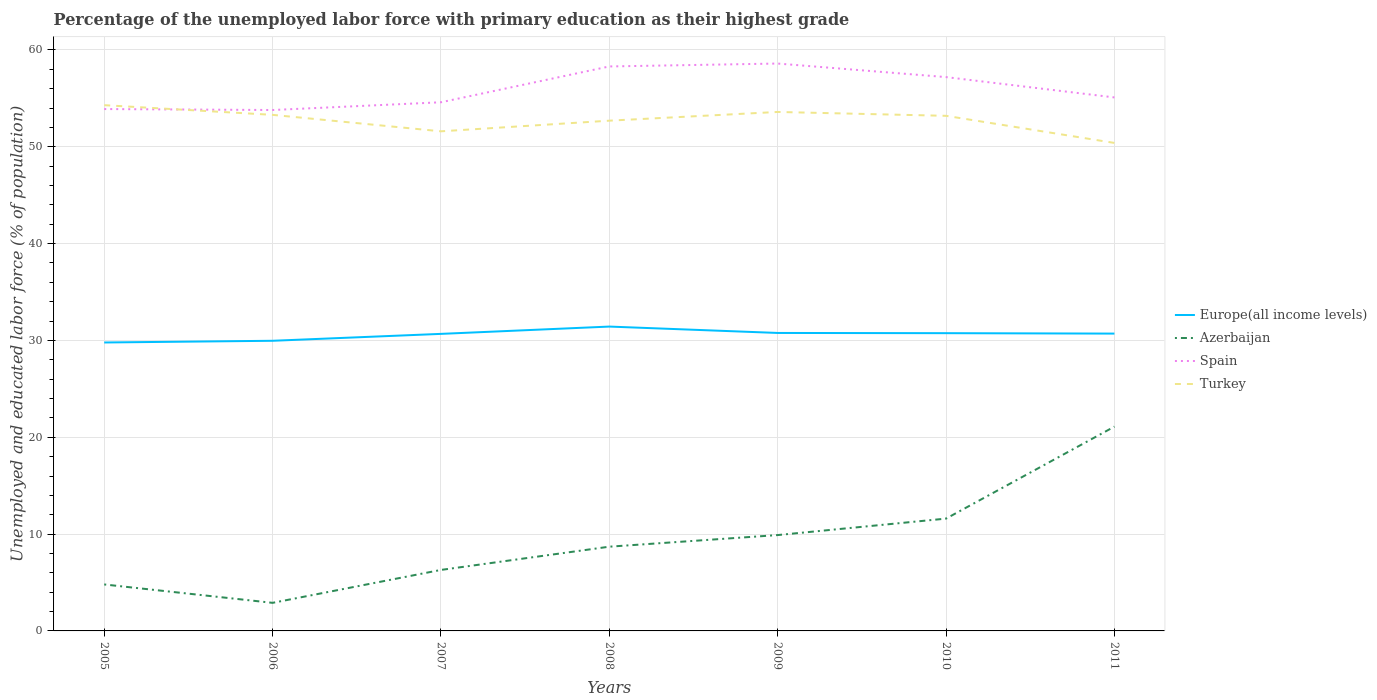How many different coloured lines are there?
Ensure brevity in your answer.  4. Does the line corresponding to Europe(all income levels) intersect with the line corresponding to Turkey?
Offer a terse response. No. Is the number of lines equal to the number of legend labels?
Ensure brevity in your answer.  Yes. Across all years, what is the maximum percentage of the unemployed labor force with primary education in Europe(all income levels)?
Provide a short and direct response. 29.79. In which year was the percentage of the unemployed labor force with primary education in Azerbaijan maximum?
Offer a terse response. 2006. What is the total percentage of the unemployed labor force with primary education in Azerbaijan in the graph?
Give a very brief answer. -3.6. What is the difference between the highest and the second highest percentage of the unemployed labor force with primary education in Turkey?
Make the answer very short. 3.9. What is the difference between the highest and the lowest percentage of the unemployed labor force with primary education in Spain?
Offer a very short reply. 3. How many lines are there?
Make the answer very short. 4. Are the values on the major ticks of Y-axis written in scientific E-notation?
Keep it short and to the point. No. Does the graph contain any zero values?
Your answer should be very brief. No. Where does the legend appear in the graph?
Keep it short and to the point. Center right. How many legend labels are there?
Your response must be concise. 4. How are the legend labels stacked?
Provide a short and direct response. Vertical. What is the title of the graph?
Your answer should be compact. Percentage of the unemployed labor force with primary education as their highest grade. What is the label or title of the Y-axis?
Provide a short and direct response. Unemployed and educated labor force (% of population). What is the Unemployed and educated labor force (% of population) of Europe(all income levels) in 2005?
Ensure brevity in your answer.  29.79. What is the Unemployed and educated labor force (% of population) of Azerbaijan in 2005?
Offer a terse response. 4.8. What is the Unemployed and educated labor force (% of population) in Spain in 2005?
Make the answer very short. 53.9. What is the Unemployed and educated labor force (% of population) of Turkey in 2005?
Give a very brief answer. 54.3. What is the Unemployed and educated labor force (% of population) in Europe(all income levels) in 2006?
Your response must be concise. 29.97. What is the Unemployed and educated labor force (% of population) of Azerbaijan in 2006?
Make the answer very short. 2.9. What is the Unemployed and educated labor force (% of population) of Spain in 2006?
Offer a very short reply. 53.8. What is the Unemployed and educated labor force (% of population) in Turkey in 2006?
Offer a very short reply. 53.3. What is the Unemployed and educated labor force (% of population) of Europe(all income levels) in 2007?
Your response must be concise. 30.68. What is the Unemployed and educated labor force (% of population) of Azerbaijan in 2007?
Offer a terse response. 6.3. What is the Unemployed and educated labor force (% of population) of Spain in 2007?
Your response must be concise. 54.6. What is the Unemployed and educated labor force (% of population) of Turkey in 2007?
Provide a short and direct response. 51.6. What is the Unemployed and educated labor force (% of population) in Europe(all income levels) in 2008?
Keep it short and to the point. 31.43. What is the Unemployed and educated labor force (% of population) of Azerbaijan in 2008?
Ensure brevity in your answer.  8.7. What is the Unemployed and educated labor force (% of population) in Spain in 2008?
Offer a terse response. 58.3. What is the Unemployed and educated labor force (% of population) of Turkey in 2008?
Provide a short and direct response. 52.7. What is the Unemployed and educated labor force (% of population) in Europe(all income levels) in 2009?
Your answer should be compact. 30.77. What is the Unemployed and educated labor force (% of population) in Azerbaijan in 2009?
Keep it short and to the point. 9.9. What is the Unemployed and educated labor force (% of population) in Spain in 2009?
Keep it short and to the point. 58.6. What is the Unemployed and educated labor force (% of population) in Turkey in 2009?
Offer a terse response. 53.6. What is the Unemployed and educated labor force (% of population) of Europe(all income levels) in 2010?
Provide a short and direct response. 30.75. What is the Unemployed and educated labor force (% of population) in Azerbaijan in 2010?
Make the answer very short. 11.6. What is the Unemployed and educated labor force (% of population) of Spain in 2010?
Keep it short and to the point. 57.2. What is the Unemployed and educated labor force (% of population) in Turkey in 2010?
Provide a succinct answer. 53.2. What is the Unemployed and educated labor force (% of population) in Europe(all income levels) in 2011?
Provide a succinct answer. 30.71. What is the Unemployed and educated labor force (% of population) in Azerbaijan in 2011?
Your response must be concise. 21.1. What is the Unemployed and educated labor force (% of population) in Spain in 2011?
Your answer should be compact. 55.1. What is the Unemployed and educated labor force (% of population) in Turkey in 2011?
Give a very brief answer. 50.4. Across all years, what is the maximum Unemployed and educated labor force (% of population) of Europe(all income levels)?
Your answer should be compact. 31.43. Across all years, what is the maximum Unemployed and educated labor force (% of population) of Azerbaijan?
Your answer should be compact. 21.1. Across all years, what is the maximum Unemployed and educated labor force (% of population) in Spain?
Your answer should be very brief. 58.6. Across all years, what is the maximum Unemployed and educated labor force (% of population) in Turkey?
Your answer should be very brief. 54.3. Across all years, what is the minimum Unemployed and educated labor force (% of population) in Europe(all income levels)?
Offer a very short reply. 29.79. Across all years, what is the minimum Unemployed and educated labor force (% of population) of Azerbaijan?
Keep it short and to the point. 2.9. Across all years, what is the minimum Unemployed and educated labor force (% of population) in Spain?
Offer a terse response. 53.8. Across all years, what is the minimum Unemployed and educated labor force (% of population) of Turkey?
Offer a very short reply. 50.4. What is the total Unemployed and educated labor force (% of population) in Europe(all income levels) in the graph?
Offer a terse response. 214.11. What is the total Unemployed and educated labor force (% of population) in Azerbaijan in the graph?
Ensure brevity in your answer.  65.3. What is the total Unemployed and educated labor force (% of population) of Spain in the graph?
Make the answer very short. 391.5. What is the total Unemployed and educated labor force (% of population) in Turkey in the graph?
Your response must be concise. 369.1. What is the difference between the Unemployed and educated labor force (% of population) of Europe(all income levels) in 2005 and that in 2006?
Provide a succinct answer. -0.17. What is the difference between the Unemployed and educated labor force (% of population) of Europe(all income levels) in 2005 and that in 2007?
Make the answer very short. -0.89. What is the difference between the Unemployed and educated labor force (% of population) in Azerbaijan in 2005 and that in 2007?
Provide a short and direct response. -1.5. What is the difference between the Unemployed and educated labor force (% of population) in Spain in 2005 and that in 2007?
Your response must be concise. -0.7. What is the difference between the Unemployed and educated labor force (% of population) in Europe(all income levels) in 2005 and that in 2008?
Offer a very short reply. -1.64. What is the difference between the Unemployed and educated labor force (% of population) of Azerbaijan in 2005 and that in 2008?
Keep it short and to the point. -3.9. What is the difference between the Unemployed and educated labor force (% of population) in Europe(all income levels) in 2005 and that in 2009?
Offer a terse response. -0.98. What is the difference between the Unemployed and educated labor force (% of population) of Azerbaijan in 2005 and that in 2009?
Keep it short and to the point. -5.1. What is the difference between the Unemployed and educated labor force (% of population) in Turkey in 2005 and that in 2009?
Ensure brevity in your answer.  0.7. What is the difference between the Unemployed and educated labor force (% of population) in Europe(all income levels) in 2005 and that in 2010?
Your answer should be compact. -0.96. What is the difference between the Unemployed and educated labor force (% of population) in Azerbaijan in 2005 and that in 2010?
Offer a terse response. -6.8. What is the difference between the Unemployed and educated labor force (% of population) of Spain in 2005 and that in 2010?
Your answer should be compact. -3.3. What is the difference between the Unemployed and educated labor force (% of population) in Turkey in 2005 and that in 2010?
Provide a short and direct response. 1.1. What is the difference between the Unemployed and educated labor force (% of population) of Europe(all income levels) in 2005 and that in 2011?
Offer a very short reply. -0.92. What is the difference between the Unemployed and educated labor force (% of population) of Azerbaijan in 2005 and that in 2011?
Offer a terse response. -16.3. What is the difference between the Unemployed and educated labor force (% of population) of Europe(all income levels) in 2006 and that in 2007?
Offer a very short reply. -0.71. What is the difference between the Unemployed and educated labor force (% of population) of Turkey in 2006 and that in 2007?
Provide a short and direct response. 1.7. What is the difference between the Unemployed and educated labor force (% of population) in Europe(all income levels) in 2006 and that in 2008?
Your answer should be compact. -1.47. What is the difference between the Unemployed and educated labor force (% of population) of Azerbaijan in 2006 and that in 2008?
Your response must be concise. -5.8. What is the difference between the Unemployed and educated labor force (% of population) in Europe(all income levels) in 2006 and that in 2009?
Keep it short and to the point. -0.81. What is the difference between the Unemployed and educated labor force (% of population) in Azerbaijan in 2006 and that in 2009?
Ensure brevity in your answer.  -7. What is the difference between the Unemployed and educated labor force (% of population) in Turkey in 2006 and that in 2009?
Your answer should be very brief. -0.3. What is the difference between the Unemployed and educated labor force (% of population) of Europe(all income levels) in 2006 and that in 2010?
Provide a succinct answer. -0.79. What is the difference between the Unemployed and educated labor force (% of population) in Azerbaijan in 2006 and that in 2010?
Provide a short and direct response. -8.7. What is the difference between the Unemployed and educated labor force (% of population) of Spain in 2006 and that in 2010?
Give a very brief answer. -3.4. What is the difference between the Unemployed and educated labor force (% of population) of Turkey in 2006 and that in 2010?
Keep it short and to the point. 0.1. What is the difference between the Unemployed and educated labor force (% of population) of Europe(all income levels) in 2006 and that in 2011?
Your answer should be very brief. -0.74. What is the difference between the Unemployed and educated labor force (% of population) of Azerbaijan in 2006 and that in 2011?
Ensure brevity in your answer.  -18.2. What is the difference between the Unemployed and educated labor force (% of population) of Spain in 2006 and that in 2011?
Give a very brief answer. -1.3. What is the difference between the Unemployed and educated labor force (% of population) of Turkey in 2006 and that in 2011?
Your response must be concise. 2.9. What is the difference between the Unemployed and educated labor force (% of population) of Europe(all income levels) in 2007 and that in 2008?
Your answer should be very brief. -0.75. What is the difference between the Unemployed and educated labor force (% of population) in Europe(all income levels) in 2007 and that in 2009?
Provide a short and direct response. -0.09. What is the difference between the Unemployed and educated labor force (% of population) in Azerbaijan in 2007 and that in 2009?
Keep it short and to the point. -3.6. What is the difference between the Unemployed and educated labor force (% of population) in Europe(all income levels) in 2007 and that in 2010?
Offer a very short reply. -0.07. What is the difference between the Unemployed and educated labor force (% of population) of Spain in 2007 and that in 2010?
Offer a terse response. -2.6. What is the difference between the Unemployed and educated labor force (% of population) of Turkey in 2007 and that in 2010?
Offer a very short reply. -1.6. What is the difference between the Unemployed and educated labor force (% of population) in Europe(all income levels) in 2007 and that in 2011?
Give a very brief answer. -0.03. What is the difference between the Unemployed and educated labor force (% of population) in Azerbaijan in 2007 and that in 2011?
Offer a very short reply. -14.8. What is the difference between the Unemployed and educated labor force (% of population) in Spain in 2007 and that in 2011?
Ensure brevity in your answer.  -0.5. What is the difference between the Unemployed and educated labor force (% of population) of Europe(all income levels) in 2008 and that in 2009?
Offer a terse response. 0.66. What is the difference between the Unemployed and educated labor force (% of population) in Turkey in 2008 and that in 2009?
Offer a very short reply. -0.9. What is the difference between the Unemployed and educated labor force (% of population) of Europe(all income levels) in 2008 and that in 2010?
Offer a very short reply. 0.68. What is the difference between the Unemployed and educated labor force (% of population) of Turkey in 2008 and that in 2010?
Offer a very short reply. -0.5. What is the difference between the Unemployed and educated labor force (% of population) of Europe(all income levels) in 2008 and that in 2011?
Keep it short and to the point. 0.73. What is the difference between the Unemployed and educated labor force (% of population) in Spain in 2008 and that in 2011?
Offer a terse response. 3.2. What is the difference between the Unemployed and educated labor force (% of population) in Turkey in 2008 and that in 2011?
Ensure brevity in your answer.  2.3. What is the difference between the Unemployed and educated labor force (% of population) of Europe(all income levels) in 2009 and that in 2010?
Keep it short and to the point. 0.02. What is the difference between the Unemployed and educated labor force (% of population) of Spain in 2009 and that in 2010?
Your answer should be very brief. 1.4. What is the difference between the Unemployed and educated labor force (% of population) in Turkey in 2009 and that in 2010?
Provide a succinct answer. 0.4. What is the difference between the Unemployed and educated labor force (% of population) in Europe(all income levels) in 2009 and that in 2011?
Your response must be concise. 0.07. What is the difference between the Unemployed and educated labor force (% of population) of Azerbaijan in 2009 and that in 2011?
Ensure brevity in your answer.  -11.2. What is the difference between the Unemployed and educated labor force (% of population) in Spain in 2009 and that in 2011?
Your answer should be compact. 3.5. What is the difference between the Unemployed and educated labor force (% of population) in Europe(all income levels) in 2010 and that in 2011?
Keep it short and to the point. 0.04. What is the difference between the Unemployed and educated labor force (% of population) in Azerbaijan in 2010 and that in 2011?
Offer a terse response. -9.5. What is the difference between the Unemployed and educated labor force (% of population) of Spain in 2010 and that in 2011?
Give a very brief answer. 2.1. What is the difference between the Unemployed and educated labor force (% of population) of Europe(all income levels) in 2005 and the Unemployed and educated labor force (% of population) of Azerbaijan in 2006?
Provide a short and direct response. 26.89. What is the difference between the Unemployed and educated labor force (% of population) in Europe(all income levels) in 2005 and the Unemployed and educated labor force (% of population) in Spain in 2006?
Keep it short and to the point. -24.01. What is the difference between the Unemployed and educated labor force (% of population) in Europe(all income levels) in 2005 and the Unemployed and educated labor force (% of population) in Turkey in 2006?
Ensure brevity in your answer.  -23.51. What is the difference between the Unemployed and educated labor force (% of population) in Azerbaijan in 2005 and the Unemployed and educated labor force (% of population) in Spain in 2006?
Your answer should be very brief. -49. What is the difference between the Unemployed and educated labor force (% of population) in Azerbaijan in 2005 and the Unemployed and educated labor force (% of population) in Turkey in 2006?
Your answer should be compact. -48.5. What is the difference between the Unemployed and educated labor force (% of population) of Europe(all income levels) in 2005 and the Unemployed and educated labor force (% of population) of Azerbaijan in 2007?
Your answer should be very brief. 23.49. What is the difference between the Unemployed and educated labor force (% of population) in Europe(all income levels) in 2005 and the Unemployed and educated labor force (% of population) in Spain in 2007?
Your answer should be very brief. -24.81. What is the difference between the Unemployed and educated labor force (% of population) of Europe(all income levels) in 2005 and the Unemployed and educated labor force (% of population) of Turkey in 2007?
Your response must be concise. -21.81. What is the difference between the Unemployed and educated labor force (% of population) of Azerbaijan in 2005 and the Unemployed and educated labor force (% of population) of Spain in 2007?
Offer a terse response. -49.8. What is the difference between the Unemployed and educated labor force (% of population) of Azerbaijan in 2005 and the Unemployed and educated labor force (% of population) of Turkey in 2007?
Provide a succinct answer. -46.8. What is the difference between the Unemployed and educated labor force (% of population) in Spain in 2005 and the Unemployed and educated labor force (% of population) in Turkey in 2007?
Give a very brief answer. 2.3. What is the difference between the Unemployed and educated labor force (% of population) of Europe(all income levels) in 2005 and the Unemployed and educated labor force (% of population) of Azerbaijan in 2008?
Offer a terse response. 21.09. What is the difference between the Unemployed and educated labor force (% of population) of Europe(all income levels) in 2005 and the Unemployed and educated labor force (% of population) of Spain in 2008?
Make the answer very short. -28.51. What is the difference between the Unemployed and educated labor force (% of population) in Europe(all income levels) in 2005 and the Unemployed and educated labor force (% of population) in Turkey in 2008?
Provide a short and direct response. -22.91. What is the difference between the Unemployed and educated labor force (% of population) of Azerbaijan in 2005 and the Unemployed and educated labor force (% of population) of Spain in 2008?
Your answer should be compact. -53.5. What is the difference between the Unemployed and educated labor force (% of population) of Azerbaijan in 2005 and the Unemployed and educated labor force (% of population) of Turkey in 2008?
Offer a very short reply. -47.9. What is the difference between the Unemployed and educated labor force (% of population) in Spain in 2005 and the Unemployed and educated labor force (% of population) in Turkey in 2008?
Provide a succinct answer. 1.2. What is the difference between the Unemployed and educated labor force (% of population) in Europe(all income levels) in 2005 and the Unemployed and educated labor force (% of population) in Azerbaijan in 2009?
Keep it short and to the point. 19.89. What is the difference between the Unemployed and educated labor force (% of population) in Europe(all income levels) in 2005 and the Unemployed and educated labor force (% of population) in Spain in 2009?
Your answer should be very brief. -28.81. What is the difference between the Unemployed and educated labor force (% of population) of Europe(all income levels) in 2005 and the Unemployed and educated labor force (% of population) of Turkey in 2009?
Give a very brief answer. -23.81. What is the difference between the Unemployed and educated labor force (% of population) in Azerbaijan in 2005 and the Unemployed and educated labor force (% of population) in Spain in 2009?
Keep it short and to the point. -53.8. What is the difference between the Unemployed and educated labor force (% of population) of Azerbaijan in 2005 and the Unemployed and educated labor force (% of population) of Turkey in 2009?
Keep it short and to the point. -48.8. What is the difference between the Unemployed and educated labor force (% of population) in Europe(all income levels) in 2005 and the Unemployed and educated labor force (% of population) in Azerbaijan in 2010?
Your answer should be very brief. 18.19. What is the difference between the Unemployed and educated labor force (% of population) of Europe(all income levels) in 2005 and the Unemployed and educated labor force (% of population) of Spain in 2010?
Your response must be concise. -27.41. What is the difference between the Unemployed and educated labor force (% of population) in Europe(all income levels) in 2005 and the Unemployed and educated labor force (% of population) in Turkey in 2010?
Offer a very short reply. -23.41. What is the difference between the Unemployed and educated labor force (% of population) of Azerbaijan in 2005 and the Unemployed and educated labor force (% of population) of Spain in 2010?
Your answer should be very brief. -52.4. What is the difference between the Unemployed and educated labor force (% of population) in Azerbaijan in 2005 and the Unemployed and educated labor force (% of population) in Turkey in 2010?
Provide a short and direct response. -48.4. What is the difference between the Unemployed and educated labor force (% of population) in Europe(all income levels) in 2005 and the Unemployed and educated labor force (% of population) in Azerbaijan in 2011?
Give a very brief answer. 8.69. What is the difference between the Unemployed and educated labor force (% of population) in Europe(all income levels) in 2005 and the Unemployed and educated labor force (% of population) in Spain in 2011?
Ensure brevity in your answer.  -25.31. What is the difference between the Unemployed and educated labor force (% of population) of Europe(all income levels) in 2005 and the Unemployed and educated labor force (% of population) of Turkey in 2011?
Offer a terse response. -20.61. What is the difference between the Unemployed and educated labor force (% of population) in Azerbaijan in 2005 and the Unemployed and educated labor force (% of population) in Spain in 2011?
Provide a short and direct response. -50.3. What is the difference between the Unemployed and educated labor force (% of population) in Azerbaijan in 2005 and the Unemployed and educated labor force (% of population) in Turkey in 2011?
Offer a terse response. -45.6. What is the difference between the Unemployed and educated labor force (% of population) of Spain in 2005 and the Unemployed and educated labor force (% of population) of Turkey in 2011?
Offer a terse response. 3.5. What is the difference between the Unemployed and educated labor force (% of population) in Europe(all income levels) in 2006 and the Unemployed and educated labor force (% of population) in Azerbaijan in 2007?
Provide a short and direct response. 23.67. What is the difference between the Unemployed and educated labor force (% of population) in Europe(all income levels) in 2006 and the Unemployed and educated labor force (% of population) in Spain in 2007?
Your answer should be very brief. -24.63. What is the difference between the Unemployed and educated labor force (% of population) of Europe(all income levels) in 2006 and the Unemployed and educated labor force (% of population) of Turkey in 2007?
Offer a very short reply. -21.63. What is the difference between the Unemployed and educated labor force (% of population) in Azerbaijan in 2006 and the Unemployed and educated labor force (% of population) in Spain in 2007?
Keep it short and to the point. -51.7. What is the difference between the Unemployed and educated labor force (% of population) of Azerbaijan in 2006 and the Unemployed and educated labor force (% of population) of Turkey in 2007?
Provide a succinct answer. -48.7. What is the difference between the Unemployed and educated labor force (% of population) of Spain in 2006 and the Unemployed and educated labor force (% of population) of Turkey in 2007?
Your answer should be very brief. 2.2. What is the difference between the Unemployed and educated labor force (% of population) in Europe(all income levels) in 2006 and the Unemployed and educated labor force (% of population) in Azerbaijan in 2008?
Ensure brevity in your answer.  21.27. What is the difference between the Unemployed and educated labor force (% of population) of Europe(all income levels) in 2006 and the Unemployed and educated labor force (% of population) of Spain in 2008?
Provide a short and direct response. -28.33. What is the difference between the Unemployed and educated labor force (% of population) in Europe(all income levels) in 2006 and the Unemployed and educated labor force (% of population) in Turkey in 2008?
Make the answer very short. -22.73. What is the difference between the Unemployed and educated labor force (% of population) of Azerbaijan in 2006 and the Unemployed and educated labor force (% of population) of Spain in 2008?
Give a very brief answer. -55.4. What is the difference between the Unemployed and educated labor force (% of population) in Azerbaijan in 2006 and the Unemployed and educated labor force (% of population) in Turkey in 2008?
Offer a very short reply. -49.8. What is the difference between the Unemployed and educated labor force (% of population) in Spain in 2006 and the Unemployed and educated labor force (% of population) in Turkey in 2008?
Offer a terse response. 1.1. What is the difference between the Unemployed and educated labor force (% of population) in Europe(all income levels) in 2006 and the Unemployed and educated labor force (% of population) in Azerbaijan in 2009?
Give a very brief answer. 20.07. What is the difference between the Unemployed and educated labor force (% of population) in Europe(all income levels) in 2006 and the Unemployed and educated labor force (% of population) in Spain in 2009?
Your answer should be compact. -28.63. What is the difference between the Unemployed and educated labor force (% of population) in Europe(all income levels) in 2006 and the Unemployed and educated labor force (% of population) in Turkey in 2009?
Offer a very short reply. -23.63. What is the difference between the Unemployed and educated labor force (% of population) in Azerbaijan in 2006 and the Unemployed and educated labor force (% of population) in Spain in 2009?
Give a very brief answer. -55.7. What is the difference between the Unemployed and educated labor force (% of population) in Azerbaijan in 2006 and the Unemployed and educated labor force (% of population) in Turkey in 2009?
Your response must be concise. -50.7. What is the difference between the Unemployed and educated labor force (% of population) in Europe(all income levels) in 2006 and the Unemployed and educated labor force (% of population) in Azerbaijan in 2010?
Keep it short and to the point. 18.37. What is the difference between the Unemployed and educated labor force (% of population) of Europe(all income levels) in 2006 and the Unemployed and educated labor force (% of population) of Spain in 2010?
Your answer should be compact. -27.23. What is the difference between the Unemployed and educated labor force (% of population) in Europe(all income levels) in 2006 and the Unemployed and educated labor force (% of population) in Turkey in 2010?
Give a very brief answer. -23.23. What is the difference between the Unemployed and educated labor force (% of population) of Azerbaijan in 2006 and the Unemployed and educated labor force (% of population) of Spain in 2010?
Provide a succinct answer. -54.3. What is the difference between the Unemployed and educated labor force (% of population) in Azerbaijan in 2006 and the Unemployed and educated labor force (% of population) in Turkey in 2010?
Your answer should be very brief. -50.3. What is the difference between the Unemployed and educated labor force (% of population) of Europe(all income levels) in 2006 and the Unemployed and educated labor force (% of population) of Azerbaijan in 2011?
Offer a terse response. 8.87. What is the difference between the Unemployed and educated labor force (% of population) of Europe(all income levels) in 2006 and the Unemployed and educated labor force (% of population) of Spain in 2011?
Keep it short and to the point. -25.13. What is the difference between the Unemployed and educated labor force (% of population) of Europe(all income levels) in 2006 and the Unemployed and educated labor force (% of population) of Turkey in 2011?
Your answer should be compact. -20.43. What is the difference between the Unemployed and educated labor force (% of population) in Azerbaijan in 2006 and the Unemployed and educated labor force (% of population) in Spain in 2011?
Provide a short and direct response. -52.2. What is the difference between the Unemployed and educated labor force (% of population) of Azerbaijan in 2006 and the Unemployed and educated labor force (% of population) of Turkey in 2011?
Provide a short and direct response. -47.5. What is the difference between the Unemployed and educated labor force (% of population) of Europe(all income levels) in 2007 and the Unemployed and educated labor force (% of population) of Azerbaijan in 2008?
Make the answer very short. 21.98. What is the difference between the Unemployed and educated labor force (% of population) in Europe(all income levels) in 2007 and the Unemployed and educated labor force (% of population) in Spain in 2008?
Your answer should be very brief. -27.62. What is the difference between the Unemployed and educated labor force (% of population) in Europe(all income levels) in 2007 and the Unemployed and educated labor force (% of population) in Turkey in 2008?
Provide a succinct answer. -22.02. What is the difference between the Unemployed and educated labor force (% of population) of Azerbaijan in 2007 and the Unemployed and educated labor force (% of population) of Spain in 2008?
Your answer should be very brief. -52. What is the difference between the Unemployed and educated labor force (% of population) in Azerbaijan in 2007 and the Unemployed and educated labor force (% of population) in Turkey in 2008?
Your response must be concise. -46.4. What is the difference between the Unemployed and educated labor force (% of population) in Spain in 2007 and the Unemployed and educated labor force (% of population) in Turkey in 2008?
Offer a terse response. 1.9. What is the difference between the Unemployed and educated labor force (% of population) of Europe(all income levels) in 2007 and the Unemployed and educated labor force (% of population) of Azerbaijan in 2009?
Ensure brevity in your answer.  20.78. What is the difference between the Unemployed and educated labor force (% of population) of Europe(all income levels) in 2007 and the Unemployed and educated labor force (% of population) of Spain in 2009?
Your answer should be compact. -27.92. What is the difference between the Unemployed and educated labor force (% of population) in Europe(all income levels) in 2007 and the Unemployed and educated labor force (% of population) in Turkey in 2009?
Keep it short and to the point. -22.92. What is the difference between the Unemployed and educated labor force (% of population) in Azerbaijan in 2007 and the Unemployed and educated labor force (% of population) in Spain in 2009?
Your answer should be compact. -52.3. What is the difference between the Unemployed and educated labor force (% of population) of Azerbaijan in 2007 and the Unemployed and educated labor force (% of population) of Turkey in 2009?
Your answer should be compact. -47.3. What is the difference between the Unemployed and educated labor force (% of population) of Europe(all income levels) in 2007 and the Unemployed and educated labor force (% of population) of Azerbaijan in 2010?
Ensure brevity in your answer.  19.08. What is the difference between the Unemployed and educated labor force (% of population) in Europe(all income levels) in 2007 and the Unemployed and educated labor force (% of population) in Spain in 2010?
Ensure brevity in your answer.  -26.52. What is the difference between the Unemployed and educated labor force (% of population) of Europe(all income levels) in 2007 and the Unemployed and educated labor force (% of population) of Turkey in 2010?
Give a very brief answer. -22.52. What is the difference between the Unemployed and educated labor force (% of population) of Azerbaijan in 2007 and the Unemployed and educated labor force (% of population) of Spain in 2010?
Keep it short and to the point. -50.9. What is the difference between the Unemployed and educated labor force (% of population) of Azerbaijan in 2007 and the Unemployed and educated labor force (% of population) of Turkey in 2010?
Give a very brief answer. -46.9. What is the difference between the Unemployed and educated labor force (% of population) of Spain in 2007 and the Unemployed and educated labor force (% of population) of Turkey in 2010?
Offer a very short reply. 1.4. What is the difference between the Unemployed and educated labor force (% of population) of Europe(all income levels) in 2007 and the Unemployed and educated labor force (% of population) of Azerbaijan in 2011?
Provide a short and direct response. 9.58. What is the difference between the Unemployed and educated labor force (% of population) of Europe(all income levels) in 2007 and the Unemployed and educated labor force (% of population) of Spain in 2011?
Provide a short and direct response. -24.42. What is the difference between the Unemployed and educated labor force (% of population) of Europe(all income levels) in 2007 and the Unemployed and educated labor force (% of population) of Turkey in 2011?
Make the answer very short. -19.72. What is the difference between the Unemployed and educated labor force (% of population) of Azerbaijan in 2007 and the Unemployed and educated labor force (% of population) of Spain in 2011?
Provide a succinct answer. -48.8. What is the difference between the Unemployed and educated labor force (% of population) of Azerbaijan in 2007 and the Unemployed and educated labor force (% of population) of Turkey in 2011?
Ensure brevity in your answer.  -44.1. What is the difference between the Unemployed and educated labor force (% of population) in Spain in 2007 and the Unemployed and educated labor force (% of population) in Turkey in 2011?
Your answer should be very brief. 4.2. What is the difference between the Unemployed and educated labor force (% of population) of Europe(all income levels) in 2008 and the Unemployed and educated labor force (% of population) of Azerbaijan in 2009?
Make the answer very short. 21.53. What is the difference between the Unemployed and educated labor force (% of population) of Europe(all income levels) in 2008 and the Unemployed and educated labor force (% of population) of Spain in 2009?
Keep it short and to the point. -27.17. What is the difference between the Unemployed and educated labor force (% of population) in Europe(all income levels) in 2008 and the Unemployed and educated labor force (% of population) in Turkey in 2009?
Your answer should be very brief. -22.17. What is the difference between the Unemployed and educated labor force (% of population) in Azerbaijan in 2008 and the Unemployed and educated labor force (% of population) in Spain in 2009?
Your response must be concise. -49.9. What is the difference between the Unemployed and educated labor force (% of population) of Azerbaijan in 2008 and the Unemployed and educated labor force (% of population) of Turkey in 2009?
Offer a very short reply. -44.9. What is the difference between the Unemployed and educated labor force (% of population) of Spain in 2008 and the Unemployed and educated labor force (% of population) of Turkey in 2009?
Make the answer very short. 4.7. What is the difference between the Unemployed and educated labor force (% of population) in Europe(all income levels) in 2008 and the Unemployed and educated labor force (% of population) in Azerbaijan in 2010?
Make the answer very short. 19.83. What is the difference between the Unemployed and educated labor force (% of population) in Europe(all income levels) in 2008 and the Unemployed and educated labor force (% of population) in Spain in 2010?
Your answer should be very brief. -25.77. What is the difference between the Unemployed and educated labor force (% of population) of Europe(all income levels) in 2008 and the Unemployed and educated labor force (% of population) of Turkey in 2010?
Ensure brevity in your answer.  -21.77. What is the difference between the Unemployed and educated labor force (% of population) of Azerbaijan in 2008 and the Unemployed and educated labor force (% of population) of Spain in 2010?
Keep it short and to the point. -48.5. What is the difference between the Unemployed and educated labor force (% of population) of Azerbaijan in 2008 and the Unemployed and educated labor force (% of population) of Turkey in 2010?
Make the answer very short. -44.5. What is the difference between the Unemployed and educated labor force (% of population) in Spain in 2008 and the Unemployed and educated labor force (% of population) in Turkey in 2010?
Make the answer very short. 5.1. What is the difference between the Unemployed and educated labor force (% of population) of Europe(all income levels) in 2008 and the Unemployed and educated labor force (% of population) of Azerbaijan in 2011?
Offer a very short reply. 10.33. What is the difference between the Unemployed and educated labor force (% of population) in Europe(all income levels) in 2008 and the Unemployed and educated labor force (% of population) in Spain in 2011?
Your answer should be compact. -23.67. What is the difference between the Unemployed and educated labor force (% of population) of Europe(all income levels) in 2008 and the Unemployed and educated labor force (% of population) of Turkey in 2011?
Provide a succinct answer. -18.97. What is the difference between the Unemployed and educated labor force (% of population) in Azerbaijan in 2008 and the Unemployed and educated labor force (% of population) in Spain in 2011?
Ensure brevity in your answer.  -46.4. What is the difference between the Unemployed and educated labor force (% of population) in Azerbaijan in 2008 and the Unemployed and educated labor force (% of population) in Turkey in 2011?
Provide a succinct answer. -41.7. What is the difference between the Unemployed and educated labor force (% of population) in Spain in 2008 and the Unemployed and educated labor force (% of population) in Turkey in 2011?
Provide a succinct answer. 7.9. What is the difference between the Unemployed and educated labor force (% of population) in Europe(all income levels) in 2009 and the Unemployed and educated labor force (% of population) in Azerbaijan in 2010?
Offer a terse response. 19.17. What is the difference between the Unemployed and educated labor force (% of population) in Europe(all income levels) in 2009 and the Unemployed and educated labor force (% of population) in Spain in 2010?
Offer a very short reply. -26.43. What is the difference between the Unemployed and educated labor force (% of population) in Europe(all income levels) in 2009 and the Unemployed and educated labor force (% of population) in Turkey in 2010?
Your answer should be very brief. -22.43. What is the difference between the Unemployed and educated labor force (% of population) of Azerbaijan in 2009 and the Unemployed and educated labor force (% of population) of Spain in 2010?
Make the answer very short. -47.3. What is the difference between the Unemployed and educated labor force (% of population) in Azerbaijan in 2009 and the Unemployed and educated labor force (% of population) in Turkey in 2010?
Keep it short and to the point. -43.3. What is the difference between the Unemployed and educated labor force (% of population) of Europe(all income levels) in 2009 and the Unemployed and educated labor force (% of population) of Azerbaijan in 2011?
Give a very brief answer. 9.67. What is the difference between the Unemployed and educated labor force (% of population) of Europe(all income levels) in 2009 and the Unemployed and educated labor force (% of population) of Spain in 2011?
Your answer should be very brief. -24.33. What is the difference between the Unemployed and educated labor force (% of population) in Europe(all income levels) in 2009 and the Unemployed and educated labor force (% of population) in Turkey in 2011?
Ensure brevity in your answer.  -19.63. What is the difference between the Unemployed and educated labor force (% of population) in Azerbaijan in 2009 and the Unemployed and educated labor force (% of population) in Spain in 2011?
Provide a short and direct response. -45.2. What is the difference between the Unemployed and educated labor force (% of population) in Azerbaijan in 2009 and the Unemployed and educated labor force (% of population) in Turkey in 2011?
Offer a very short reply. -40.5. What is the difference between the Unemployed and educated labor force (% of population) in Europe(all income levels) in 2010 and the Unemployed and educated labor force (% of population) in Azerbaijan in 2011?
Give a very brief answer. 9.65. What is the difference between the Unemployed and educated labor force (% of population) in Europe(all income levels) in 2010 and the Unemployed and educated labor force (% of population) in Spain in 2011?
Ensure brevity in your answer.  -24.35. What is the difference between the Unemployed and educated labor force (% of population) of Europe(all income levels) in 2010 and the Unemployed and educated labor force (% of population) of Turkey in 2011?
Give a very brief answer. -19.65. What is the difference between the Unemployed and educated labor force (% of population) of Azerbaijan in 2010 and the Unemployed and educated labor force (% of population) of Spain in 2011?
Provide a short and direct response. -43.5. What is the difference between the Unemployed and educated labor force (% of population) in Azerbaijan in 2010 and the Unemployed and educated labor force (% of population) in Turkey in 2011?
Ensure brevity in your answer.  -38.8. What is the difference between the Unemployed and educated labor force (% of population) in Spain in 2010 and the Unemployed and educated labor force (% of population) in Turkey in 2011?
Provide a succinct answer. 6.8. What is the average Unemployed and educated labor force (% of population) in Europe(all income levels) per year?
Keep it short and to the point. 30.59. What is the average Unemployed and educated labor force (% of population) of Azerbaijan per year?
Keep it short and to the point. 9.33. What is the average Unemployed and educated labor force (% of population) in Spain per year?
Offer a very short reply. 55.93. What is the average Unemployed and educated labor force (% of population) of Turkey per year?
Make the answer very short. 52.73. In the year 2005, what is the difference between the Unemployed and educated labor force (% of population) of Europe(all income levels) and Unemployed and educated labor force (% of population) of Azerbaijan?
Provide a short and direct response. 24.99. In the year 2005, what is the difference between the Unemployed and educated labor force (% of population) in Europe(all income levels) and Unemployed and educated labor force (% of population) in Spain?
Your answer should be compact. -24.11. In the year 2005, what is the difference between the Unemployed and educated labor force (% of population) of Europe(all income levels) and Unemployed and educated labor force (% of population) of Turkey?
Offer a very short reply. -24.51. In the year 2005, what is the difference between the Unemployed and educated labor force (% of population) of Azerbaijan and Unemployed and educated labor force (% of population) of Spain?
Your answer should be compact. -49.1. In the year 2005, what is the difference between the Unemployed and educated labor force (% of population) in Azerbaijan and Unemployed and educated labor force (% of population) in Turkey?
Make the answer very short. -49.5. In the year 2005, what is the difference between the Unemployed and educated labor force (% of population) of Spain and Unemployed and educated labor force (% of population) of Turkey?
Offer a very short reply. -0.4. In the year 2006, what is the difference between the Unemployed and educated labor force (% of population) of Europe(all income levels) and Unemployed and educated labor force (% of population) of Azerbaijan?
Your response must be concise. 27.07. In the year 2006, what is the difference between the Unemployed and educated labor force (% of population) in Europe(all income levels) and Unemployed and educated labor force (% of population) in Spain?
Ensure brevity in your answer.  -23.83. In the year 2006, what is the difference between the Unemployed and educated labor force (% of population) in Europe(all income levels) and Unemployed and educated labor force (% of population) in Turkey?
Provide a short and direct response. -23.33. In the year 2006, what is the difference between the Unemployed and educated labor force (% of population) of Azerbaijan and Unemployed and educated labor force (% of population) of Spain?
Your answer should be very brief. -50.9. In the year 2006, what is the difference between the Unemployed and educated labor force (% of population) of Azerbaijan and Unemployed and educated labor force (% of population) of Turkey?
Keep it short and to the point. -50.4. In the year 2006, what is the difference between the Unemployed and educated labor force (% of population) in Spain and Unemployed and educated labor force (% of population) in Turkey?
Your answer should be very brief. 0.5. In the year 2007, what is the difference between the Unemployed and educated labor force (% of population) in Europe(all income levels) and Unemployed and educated labor force (% of population) in Azerbaijan?
Provide a succinct answer. 24.38. In the year 2007, what is the difference between the Unemployed and educated labor force (% of population) in Europe(all income levels) and Unemployed and educated labor force (% of population) in Spain?
Make the answer very short. -23.92. In the year 2007, what is the difference between the Unemployed and educated labor force (% of population) of Europe(all income levels) and Unemployed and educated labor force (% of population) of Turkey?
Keep it short and to the point. -20.92. In the year 2007, what is the difference between the Unemployed and educated labor force (% of population) in Azerbaijan and Unemployed and educated labor force (% of population) in Spain?
Provide a succinct answer. -48.3. In the year 2007, what is the difference between the Unemployed and educated labor force (% of population) in Azerbaijan and Unemployed and educated labor force (% of population) in Turkey?
Provide a succinct answer. -45.3. In the year 2007, what is the difference between the Unemployed and educated labor force (% of population) in Spain and Unemployed and educated labor force (% of population) in Turkey?
Your answer should be compact. 3. In the year 2008, what is the difference between the Unemployed and educated labor force (% of population) of Europe(all income levels) and Unemployed and educated labor force (% of population) of Azerbaijan?
Keep it short and to the point. 22.73. In the year 2008, what is the difference between the Unemployed and educated labor force (% of population) of Europe(all income levels) and Unemployed and educated labor force (% of population) of Spain?
Give a very brief answer. -26.87. In the year 2008, what is the difference between the Unemployed and educated labor force (% of population) in Europe(all income levels) and Unemployed and educated labor force (% of population) in Turkey?
Your response must be concise. -21.27. In the year 2008, what is the difference between the Unemployed and educated labor force (% of population) of Azerbaijan and Unemployed and educated labor force (% of population) of Spain?
Offer a very short reply. -49.6. In the year 2008, what is the difference between the Unemployed and educated labor force (% of population) in Azerbaijan and Unemployed and educated labor force (% of population) in Turkey?
Your answer should be compact. -44. In the year 2008, what is the difference between the Unemployed and educated labor force (% of population) of Spain and Unemployed and educated labor force (% of population) of Turkey?
Make the answer very short. 5.6. In the year 2009, what is the difference between the Unemployed and educated labor force (% of population) of Europe(all income levels) and Unemployed and educated labor force (% of population) of Azerbaijan?
Your response must be concise. 20.87. In the year 2009, what is the difference between the Unemployed and educated labor force (% of population) in Europe(all income levels) and Unemployed and educated labor force (% of population) in Spain?
Your answer should be compact. -27.83. In the year 2009, what is the difference between the Unemployed and educated labor force (% of population) of Europe(all income levels) and Unemployed and educated labor force (% of population) of Turkey?
Ensure brevity in your answer.  -22.83. In the year 2009, what is the difference between the Unemployed and educated labor force (% of population) of Azerbaijan and Unemployed and educated labor force (% of population) of Spain?
Make the answer very short. -48.7. In the year 2009, what is the difference between the Unemployed and educated labor force (% of population) of Azerbaijan and Unemployed and educated labor force (% of population) of Turkey?
Keep it short and to the point. -43.7. In the year 2010, what is the difference between the Unemployed and educated labor force (% of population) in Europe(all income levels) and Unemployed and educated labor force (% of population) in Azerbaijan?
Provide a succinct answer. 19.15. In the year 2010, what is the difference between the Unemployed and educated labor force (% of population) in Europe(all income levels) and Unemployed and educated labor force (% of population) in Spain?
Make the answer very short. -26.45. In the year 2010, what is the difference between the Unemployed and educated labor force (% of population) in Europe(all income levels) and Unemployed and educated labor force (% of population) in Turkey?
Give a very brief answer. -22.45. In the year 2010, what is the difference between the Unemployed and educated labor force (% of population) in Azerbaijan and Unemployed and educated labor force (% of population) in Spain?
Ensure brevity in your answer.  -45.6. In the year 2010, what is the difference between the Unemployed and educated labor force (% of population) of Azerbaijan and Unemployed and educated labor force (% of population) of Turkey?
Ensure brevity in your answer.  -41.6. In the year 2010, what is the difference between the Unemployed and educated labor force (% of population) in Spain and Unemployed and educated labor force (% of population) in Turkey?
Provide a succinct answer. 4. In the year 2011, what is the difference between the Unemployed and educated labor force (% of population) of Europe(all income levels) and Unemployed and educated labor force (% of population) of Azerbaijan?
Offer a terse response. 9.61. In the year 2011, what is the difference between the Unemployed and educated labor force (% of population) of Europe(all income levels) and Unemployed and educated labor force (% of population) of Spain?
Give a very brief answer. -24.39. In the year 2011, what is the difference between the Unemployed and educated labor force (% of population) of Europe(all income levels) and Unemployed and educated labor force (% of population) of Turkey?
Offer a very short reply. -19.69. In the year 2011, what is the difference between the Unemployed and educated labor force (% of population) in Azerbaijan and Unemployed and educated labor force (% of population) in Spain?
Offer a terse response. -34. In the year 2011, what is the difference between the Unemployed and educated labor force (% of population) of Azerbaijan and Unemployed and educated labor force (% of population) of Turkey?
Your answer should be compact. -29.3. In the year 2011, what is the difference between the Unemployed and educated labor force (% of population) of Spain and Unemployed and educated labor force (% of population) of Turkey?
Offer a very short reply. 4.7. What is the ratio of the Unemployed and educated labor force (% of population) in Europe(all income levels) in 2005 to that in 2006?
Provide a short and direct response. 0.99. What is the ratio of the Unemployed and educated labor force (% of population) in Azerbaijan in 2005 to that in 2006?
Offer a very short reply. 1.66. What is the ratio of the Unemployed and educated labor force (% of population) in Turkey in 2005 to that in 2006?
Your answer should be compact. 1.02. What is the ratio of the Unemployed and educated labor force (% of population) in Azerbaijan in 2005 to that in 2007?
Provide a succinct answer. 0.76. What is the ratio of the Unemployed and educated labor force (% of population) in Spain in 2005 to that in 2007?
Your response must be concise. 0.99. What is the ratio of the Unemployed and educated labor force (% of population) of Turkey in 2005 to that in 2007?
Make the answer very short. 1.05. What is the ratio of the Unemployed and educated labor force (% of population) in Europe(all income levels) in 2005 to that in 2008?
Make the answer very short. 0.95. What is the ratio of the Unemployed and educated labor force (% of population) in Azerbaijan in 2005 to that in 2008?
Your response must be concise. 0.55. What is the ratio of the Unemployed and educated labor force (% of population) of Spain in 2005 to that in 2008?
Give a very brief answer. 0.92. What is the ratio of the Unemployed and educated labor force (% of population) of Turkey in 2005 to that in 2008?
Your answer should be compact. 1.03. What is the ratio of the Unemployed and educated labor force (% of population) in Europe(all income levels) in 2005 to that in 2009?
Provide a succinct answer. 0.97. What is the ratio of the Unemployed and educated labor force (% of population) in Azerbaijan in 2005 to that in 2009?
Give a very brief answer. 0.48. What is the ratio of the Unemployed and educated labor force (% of population) in Spain in 2005 to that in 2009?
Provide a succinct answer. 0.92. What is the ratio of the Unemployed and educated labor force (% of population) of Turkey in 2005 to that in 2009?
Offer a very short reply. 1.01. What is the ratio of the Unemployed and educated labor force (% of population) in Europe(all income levels) in 2005 to that in 2010?
Your answer should be very brief. 0.97. What is the ratio of the Unemployed and educated labor force (% of population) of Azerbaijan in 2005 to that in 2010?
Make the answer very short. 0.41. What is the ratio of the Unemployed and educated labor force (% of population) of Spain in 2005 to that in 2010?
Give a very brief answer. 0.94. What is the ratio of the Unemployed and educated labor force (% of population) of Turkey in 2005 to that in 2010?
Keep it short and to the point. 1.02. What is the ratio of the Unemployed and educated labor force (% of population) of Europe(all income levels) in 2005 to that in 2011?
Your response must be concise. 0.97. What is the ratio of the Unemployed and educated labor force (% of population) in Azerbaijan in 2005 to that in 2011?
Your answer should be compact. 0.23. What is the ratio of the Unemployed and educated labor force (% of population) in Spain in 2005 to that in 2011?
Your response must be concise. 0.98. What is the ratio of the Unemployed and educated labor force (% of population) of Turkey in 2005 to that in 2011?
Offer a terse response. 1.08. What is the ratio of the Unemployed and educated labor force (% of population) of Europe(all income levels) in 2006 to that in 2007?
Offer a very short reply. 0.98. What is the ratio of the Unemployed and educated labor force (% of population) of Azerbaijan in 2006 to that in 2007?
Offer a very short reply. 0.46. What is the ratio of the Unemployed and educated labor force (% of population) of Spain in 2006 to that in 2007?
Offer a terse response. 0.99. What is the ratio of the Unemployed and educated labor force (% of population) in Turkey in 2006 to that in 2007?
Give a very brief answer. 1.03. What is the ratio of the Unemployed and educated labor force (% of population) of Europe(all income levels) in 2006 to that in 2008?
Make the answer very short. 0.95. What is the ratio of the Unemployed and educated labor force (% of population) in Azerbaijan in 2006 to that in 2008?
Keep it short and to the point. 0.33. What is the ratio of the Unemployed and educated labor force (% of population) in Spain in 2006 to that in 2008?
Provide a succinct answer. 0.92. What is the ratio of the Unemployed and educated labor force (% of population) of Turkey in 2006 to that in 2008?
Provide a succinct answer. 1.01. What is the ratio of the Unemployed and educated labor force (% of population) of Europe(all income levels) in 2006 to that in 2009?
Give a very brief answer. 0.97. What is the ratio of the Unemployed and educated labor force (% of population) in Azerbaijan in 2006 to that in 2009?
Keep it short and to the point. 0.29. What is the ratio of the Unemployed and educated labor force (% of population) of Spain in 2006 to that in 2009?
Make the answer very short. 0.92. What is the ratio of the Unemployed and educated labor force (% of population) of Europe(all income levels) in 2006 to that in 2010?
Your answer should be very brief. 0.97. What is the ratio of the Unemployed and educated labor force (% of population) in Spain in 2006 to that in 2010?
Provide a succinct answer. 0.94. What is the ratio of the Unemployed and educated labor force (% of population) in Europe(all income levels) in 2006 to that in 2011?
Your response must be concise. 0.98. What is the ratio of the Unemployed and educated labor force (% of population) in Azerbaijan in 2006 to that in 2011?
Ensure brevity in your answer.  0.14. What is the ratio of the Unemployed and educated labor force (% of population) of Spain in 2006 to that in 2011?
Provide a short and direct response. 0.98. What is the ratio of the Unemployed and educated labor force (% of population) of Turkey in 2006 to that in 2011?
Your response must be concise. 1.06. What is the ratio of the Unemployed and educated labor force (% of population) in Europe(all income levels) in 2007 to that in 2008?
Provide a short and direct response. 0.98. What is the ratio of the Unemployed and educated labor force (% of population) of Azerbaijan in 2007 to that in 2008?
Give a very brief answer. 0.72. What is the ratio of the Unemployed and educated labor force (% of population) in Spain in 2007 to that in 2008?
Your answer should be very brief. 0.94. What is the ratio of the Unemployed and educated labor force (% of population) in Turkey in 2007 to that in 2008?
Provide a short and direct response. 0.98. What is the ratio of the Unemployed and educated labor force (% of population) in Europe(all income levels) in 2007 to that in 2009?
Offer a terse response. 1. What is the ratio of the Unemployed and educated labor force (% of population) in Azerbaijan in 2007 to that in 2009?
Offer a terse response. 0.64. What is the ratio of the Unemployed and educated labor force (% of population) of Spain in 2007 to that in 2009?
Offer a terse response. 0.93. What is the ratio of the Unemployed and educated labor force (% of population) of Turkey in 2007 to that in 2009?
Provide a short and direct response. 0.96. What is the ratio of the Unemployed and educated labor force (% of population) in Azerbaijan in 2007 to that in 2010?
Your answer should be compact. 0.54. What is the ratio of the Unemployed and educated labor force (% of population) of Spain in 2007 to that in 2010?
Your response must be concise. 0.95. What is the ratio of the Unemployed and educated labor force (% of population) in Turkey in 2007 to that in 2010?
Offer a very short reply. 0.97. What is the ratio of the Unemployed and educated labor force (% of population) in Azerbaijan in 2007 to that in 2011?
Make the answer very short. 0.3. What is the ratio of the Unemployed and educated labor force (% of population) of Spain in 2007 to that in 2011?
Keep it short and to the point. 0.99. What is the ratio of the Unemployed and educated labor force (% of population) of Turkey in 2007 to that in 2011?
Your answer should be compact. 1.02. What is the ratio of the Unemployed and educated labor force (% of population) of Europe(all income levels) in 2008 to that in 2009?
Provide a short and direct response. 1.02. What is the ratio of the Unemployed and educated labor force (% of population) of Azerbaijan in 2008 to that in 2009?
Give a very brief answer. 0.88. What is the ratio of the Unemployed and educated labor force (% of population) in Spain in 2008 to that in 2009?
Offer a terse response. 0.99. What is the ratio of the Unemployed and educated labor force (% of population) of Turkey in 2008 to that in 2009?
Provide a short and direct response. 0.98. What is the ratio of the Unemployed and educated labor force (% of population) in Europe(all income levels) in 2008 to that in 2010?
Make the answer very short. 1.02. What is the ratio of the Unemployed and educated labor force (% of population) in Azerbaijan in 2008 to that in 2010?
Offer a terse response. 0.75. What is the ratio of the Unemployed and educated labor force (% of population) in Spain in 2008 to that in 2010?
Your response must be concise. 1.02. What is the ratio of the Unemployed and educated labor force (% of population) in Turkey in 2008 to that in 2010?
Provide a succinct answer. 0.99. What is the ratio of the Unemployed and educated labor force (% of population) of Europe(all income levels) in 2008 to that in 2011?
Your response must be concise. 1.02. What is the ratio of the Unemployed and educated labor force (% of population) in Azerbaijan in 2008 to that in 2011?
Keep it short and to the point. 0.41. What is the ratio of the Unemployed and educated labor force (% of population) of Spain in 2008 to that in 2011?
Keep it short and to the point. 1.06. What is the ratio of the Unemployed and educated labor force (% of population) in Turkey in 2008 to that in 2011?
Your response must be concise. 1.05. What is the ratio of the Unemployed and educated labor force (% of population) of Azerbaijan in 2009 to that in 2010?
Your response must be concise. 0.85. What is the ratio of the Unemployed and educated labor force (% of population) of Spain in 2009 to that in 2010?
Keep it short and to the point. 1.02. What is the ratio of the Unemployed and educated labor force (% of population) in Turkey in 2009 to that in 2010?
Ensure brevity in your answer.  1.01. What is the ratio of the Unemployed and educated labor force (% of population) of Europe(all income levels) in 2009 to that in 2011?
Make the answer very short. 1. What is the ratio of the Unemployed and educated labor force (% of population) of Azerbaijan in 2009 to that in 2011?
Keep it short and to the point. 0.47. What is the ratio of the Unemployed and educated labor force (% of population) of Spain in 2009 to that in 2011?
Make the answer very short. 1.06. What is the ratio of the Unemployed and educated labor force (% of population) of Turkey in 2009 to that in 2011?
Keep it short and to the point. 1.06. What is the ratio of the Unemployed and educated labor force (% of population) in Azerbaijan in 2010 to that in 2011?
Give a very brief answer. 0.55. What is the ratio of the Unemployed and educated labor force (% of population) in Spain in 2010 to that in 2011?
Your response must be concise. 1.04. What is the ratio of the Unemployed and educated labor force (% of population) in Turkey in 2010 to that in 2011?
Offer a very short reply. 1.06. What is the difference between the highest and the second highest Unemployed and educated labor force (% of population) of Europe(all income levels)?
Offer a terse response. 0.66. What is the difference between the highest and the lowest Unemployed and educated labor force (% of population) of Europe(all income levels)?
Provide a succinct answer. 1.64. 